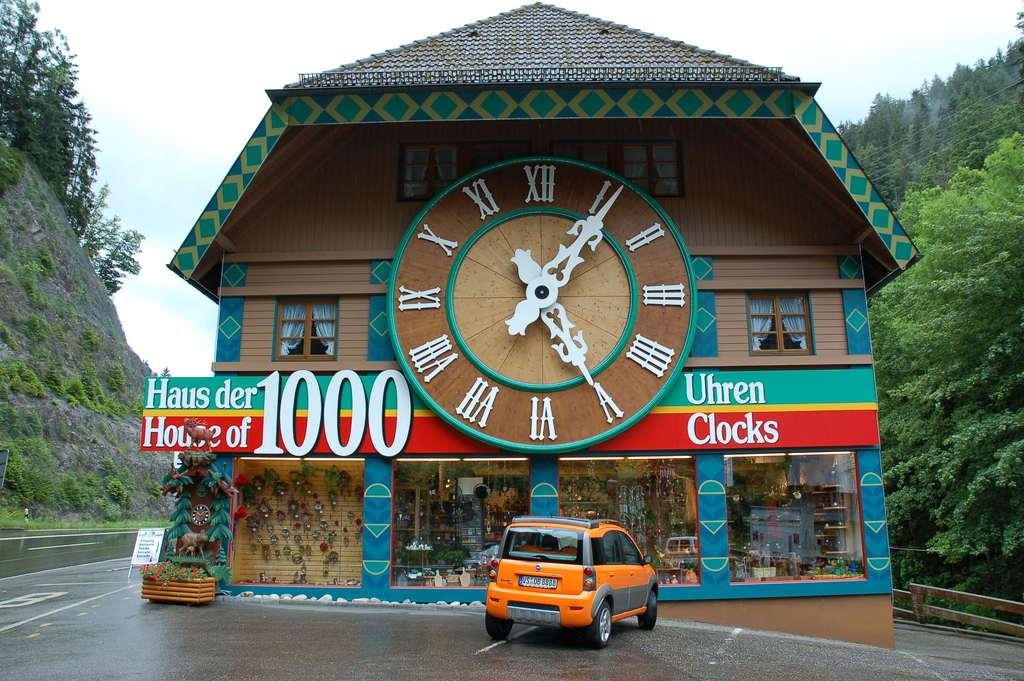<image>
Provide a brief description of the given image. Store front with the number 1000 in the front. 